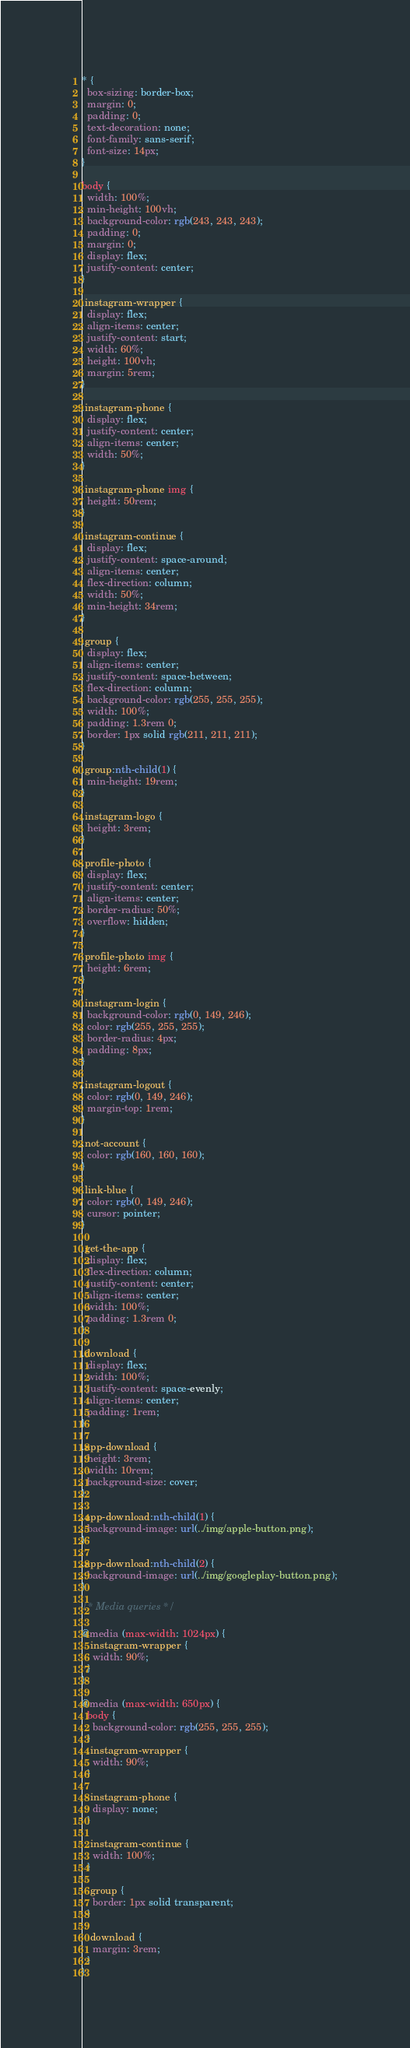Convert code to text. <code><loc_0><loc_0><loc_500><loc_500><_CSS_>* {
  box-sizing: border-box;
  margin: 0;
  padding: 0;
  text-decoration: none;
  font-family: sans-serif;
  font-size: 14px;
}

body {
  width: 100%;
  min-height: 100vh;
  background-color: rgb(243, 243, 243);
  padding: 0;
  margin: 0;
  display: flex;
  justify-content: center;
}

.instagram-wrapper {
  display: flex;
  align-items: center;
  justify-content: start;
  width: 60%;
  height: 100vh;
  margin: 5rem;
}

.instagram-phone {
  display: flex;
  justify-content: center;
  align-items: center;
  width: 50%;
}

.instagram-phone img {
  height: 50rem;
}

.instagram-continue {
  display: flex;
  justify-content: space-around;
  align-items: center;
  flex-direction: column;
  width: 50%;
  min-height: 34rem;
}

.group {
  display: flex;
  align-items: center;
  justify-content: space-between;
  flex-direction: column;
  background-color: rgb(255, 255, 255);
  width: 100%;
  padding: 1.3rem 0;
  border: 1px solid rgb(211, 211, 211);
}

.group:nth-child(1) {
  min-height: 19rem;
}

.instagram-logo {
  height: 3rem;
}

.profile-photo {
  display: flex;
  justify-content: center;
  align-items: center;
  border-radius: 50%;
  overflow: hidden;
}

.profile-photo img {
  height: 6rem;
}

.instagram-login {
  background-color: rgb(0, 149, 246);
  color: rgb(255, 255, 255);
  border-radius: 4px;
  padding: 8px;
}

.instagram-logout {
  color: rgb(0, 149, 246);
  margin-top: 1rem;
}

.not-account {
  color: rgb(160, 160, 160);
}

.link-blue {
  color: rgb(0, 149, 246);
  cursor: pointer;
}

.get-the-app {
  display: flex;
  flex-direction: column;
  justify-content: center;
  align-items: center;
  width: 100%;
  padding: 1.3rem 0;
}

.download {
  display: flex;
  width: 100%;
  justify-content: space-evenly;
  align-items: center;
  padding: 1rem;
}

.app-download {
  height: 3rem;
  width: 10rem;
  background-size: cover;
}

.app-download:nth-child(1) {
  background-image: url(../img/apple-button.png);
}

.app-download:nth-child(2) {
  background-image: url(../img/googleplay-button.png);
}

/* Media queries */

@media (max-width: 1024px) {
  .instagram-wrapper {
    width: 90%;
  }
}

@media (max-width: 650px) {
  body {
    background-color: rgb(255, 255, 255);
  }
  .instagram-wrapper {
    width: 90%;
  }

  .instagram-phone {
    display: none;
  }

  .instagram-continue {
    width: 100%;
  }

  .group {
    border: 1px solid transparent;
  }

  .download {
    margin: 3rem;
  }
}
</code> 